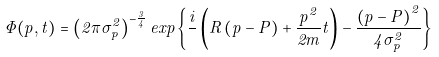<formula> <loc_0><loc_0><loc_500><loc_500>\Phi ( { p } , t ) = \left ( 2 \pi \sigma _ { p } ^ { 2 } \right ) ^ { - \frac { 3 } { 4 } } e x p \left \{ \frac { i } { } \left ( { R } \left ( { p } - { P } \right ) + \frac { { p } ^ { 2 } } { 2 m } t \right ) - \frac { \left ( { p } - { P } \right ) ^ { 2 } } { 4 \sigma _ { p } ^ { 2 } } \right \}</formula> 